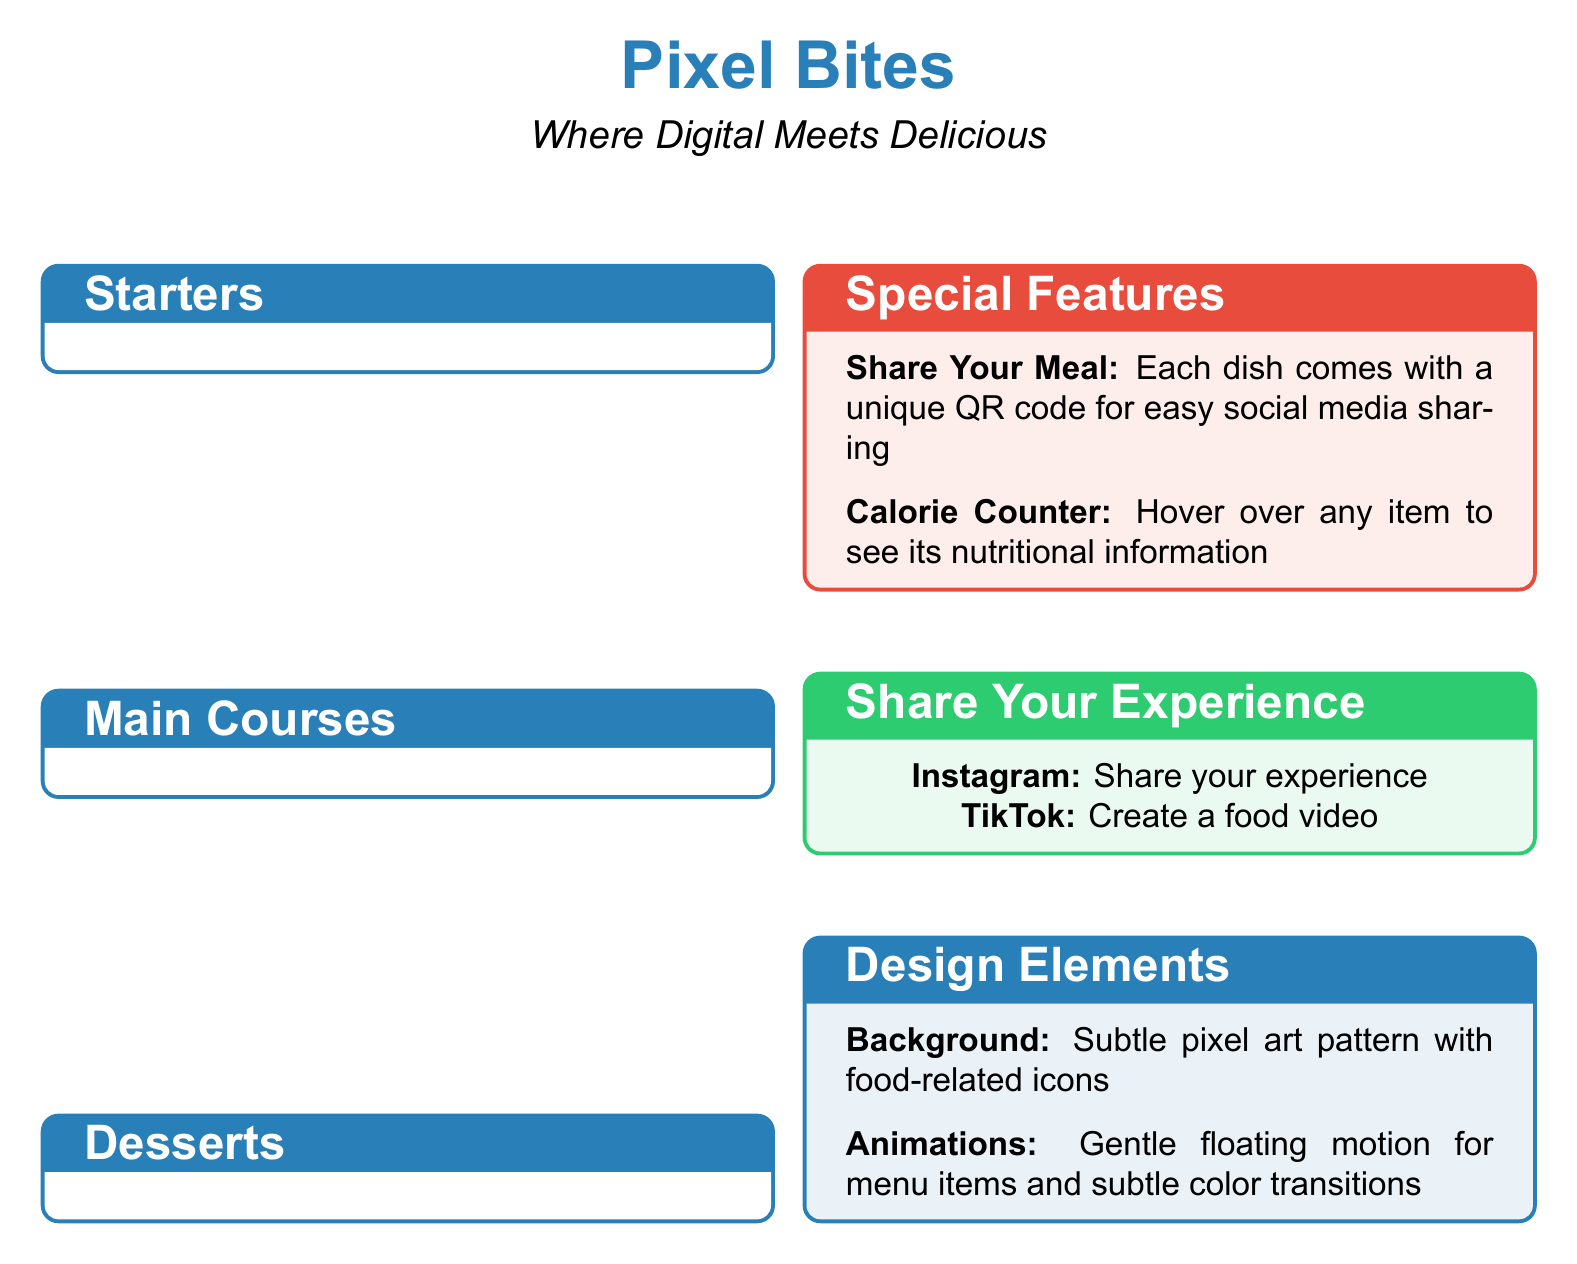What is the name of the restaurant? The document clearly states the restaurant's name at the beginning.
Answer: Pixel Bites How much does the Interactive Pizza Builder cost? The price is explicitly listed next to the dish in the Main Courses section.
Answer: $18 What feature allows users to share their meal on social media? This information is provided in the Special Features section of the menu document.
Answer: Unique QR code How many categories are in the menu? The menu includes three distinct categories according to the structure of the document.
Answer: Three What happens to the emoji you choose in the Emoji Sundae? The document specifies this unique feature under the Desserts section.
Answer: Change flavors Which color is associated with the design elements in the document? The color is referenced in the design elements section detailing the aesthetic.
Answer: Pixel blue What technology is used to show nutritional info for the Augmented Reality Sushi Platter? This is explained in the description of the specific dish under Main Courses.
Answer: Augmented Reality What type of animations are featured in the menu? The document describes the type of animations incorporated within the design elements section.
Answer: Gentle floating motion 